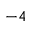<formula> <loc_0><loc_0><loc_500><loc_500>- 4</formula> 